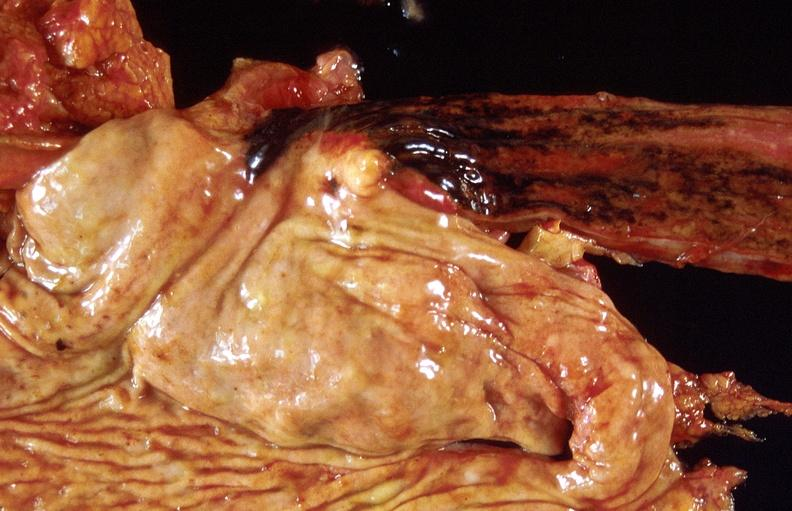does this image show stress ulcers, stomach?
Answer the question using a single word or phrase. Yes 